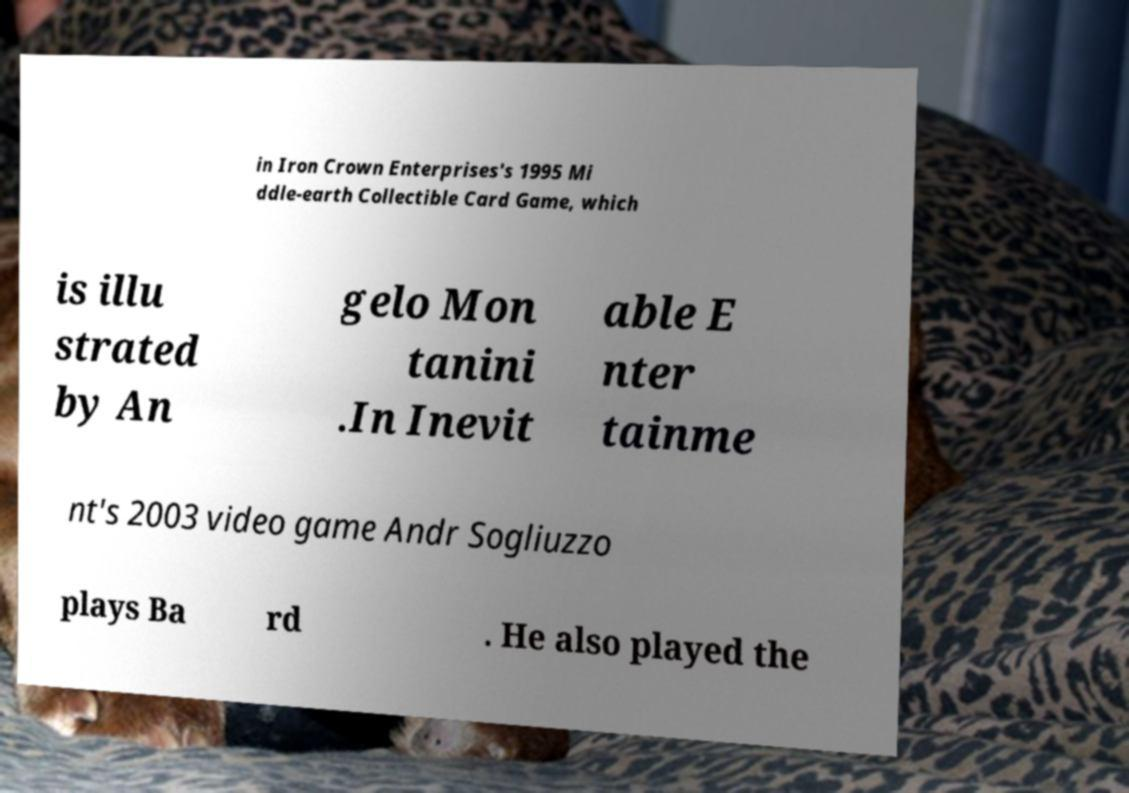There's text embedded in this image that I need extracted. Can you transcribe it verbatim? in Iron Crown Enterprises's 1995 Mi ddle-earth Collectible Card Game, which is illu strated by An gelo Mon tanini .In Inevit able E nter tainme nt's 2003 video game Andr Sogliuzzo plays Ba rd . He also played the 